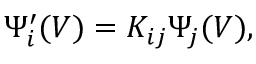Convert formula to latex. <formula><loc_0><loc_0><loc_500><loc_500>\Psi _ { i } ^ { \prime } ( V ) = K _ { i j } { \Psi } _ { j } ( V ) ,</formula> 